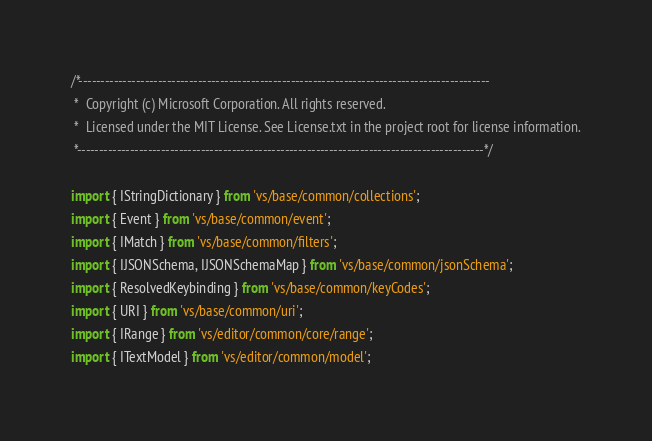Convert code to text. <code><loc_0><loc_0><loc_500><loc_500><_TypeScript_>/*---------------------------------------------------------------------------------------------
 *  Copyright (c) Microsoft Corporation. All rights reserved.
 *  Licensed under the MIT License. See License.txt in the project root for license information.
 *--------------------------------------------------------------------------------------------*/

import { IStringDictionary } from 'vs/base/common/collections';
import { Event } from 'vs/base/common/event';
import { IMatch } from 'vs/base/common/filters';
import { IJSONSchema, IJSONSchemaMap } from 'vs/base/common/jsonSchema';
import { ResolvedKeybinding } from 'vs/base/common/keyCodes';
import { URI } from 'vs/base/common/uri';
import { IRange } from 'vs/editor/common/core/range';
import { ITextModel } from 'vs/editor/common/model';</code> 